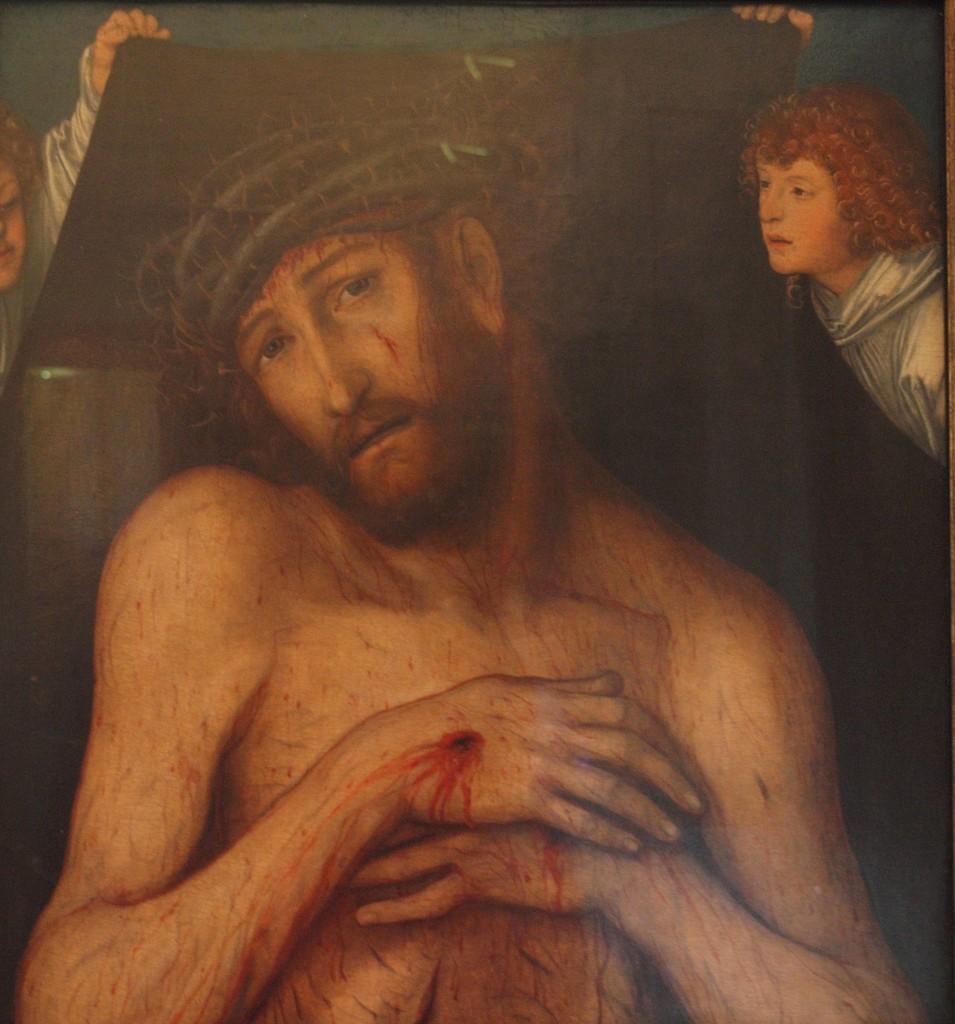How would you summarize this image in a sentence or two? In this picture we can see the painting of a man and painting of two other persons holding some object. 